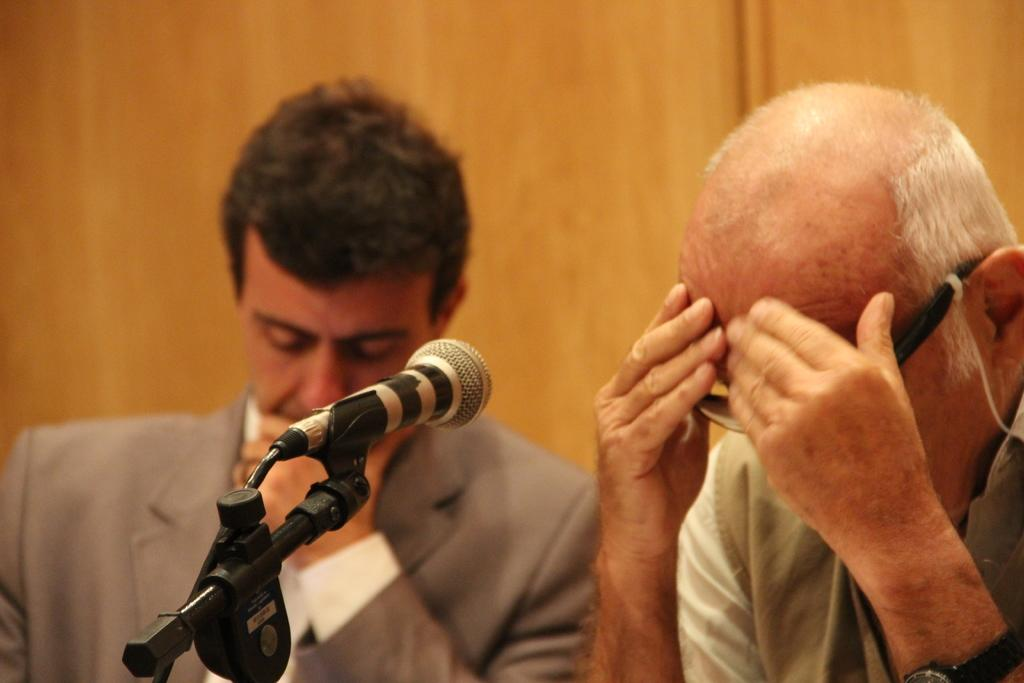How many people are in the image? There are two men in the image. What are the men doing in the image? The men are sitting. What object can be seen in the image that is related to speaking or performing? There is a microphone in the image. How many kittens are playing with the microphone in the image? There are no kittens present in the image, and therefore no such activity can be observed. 